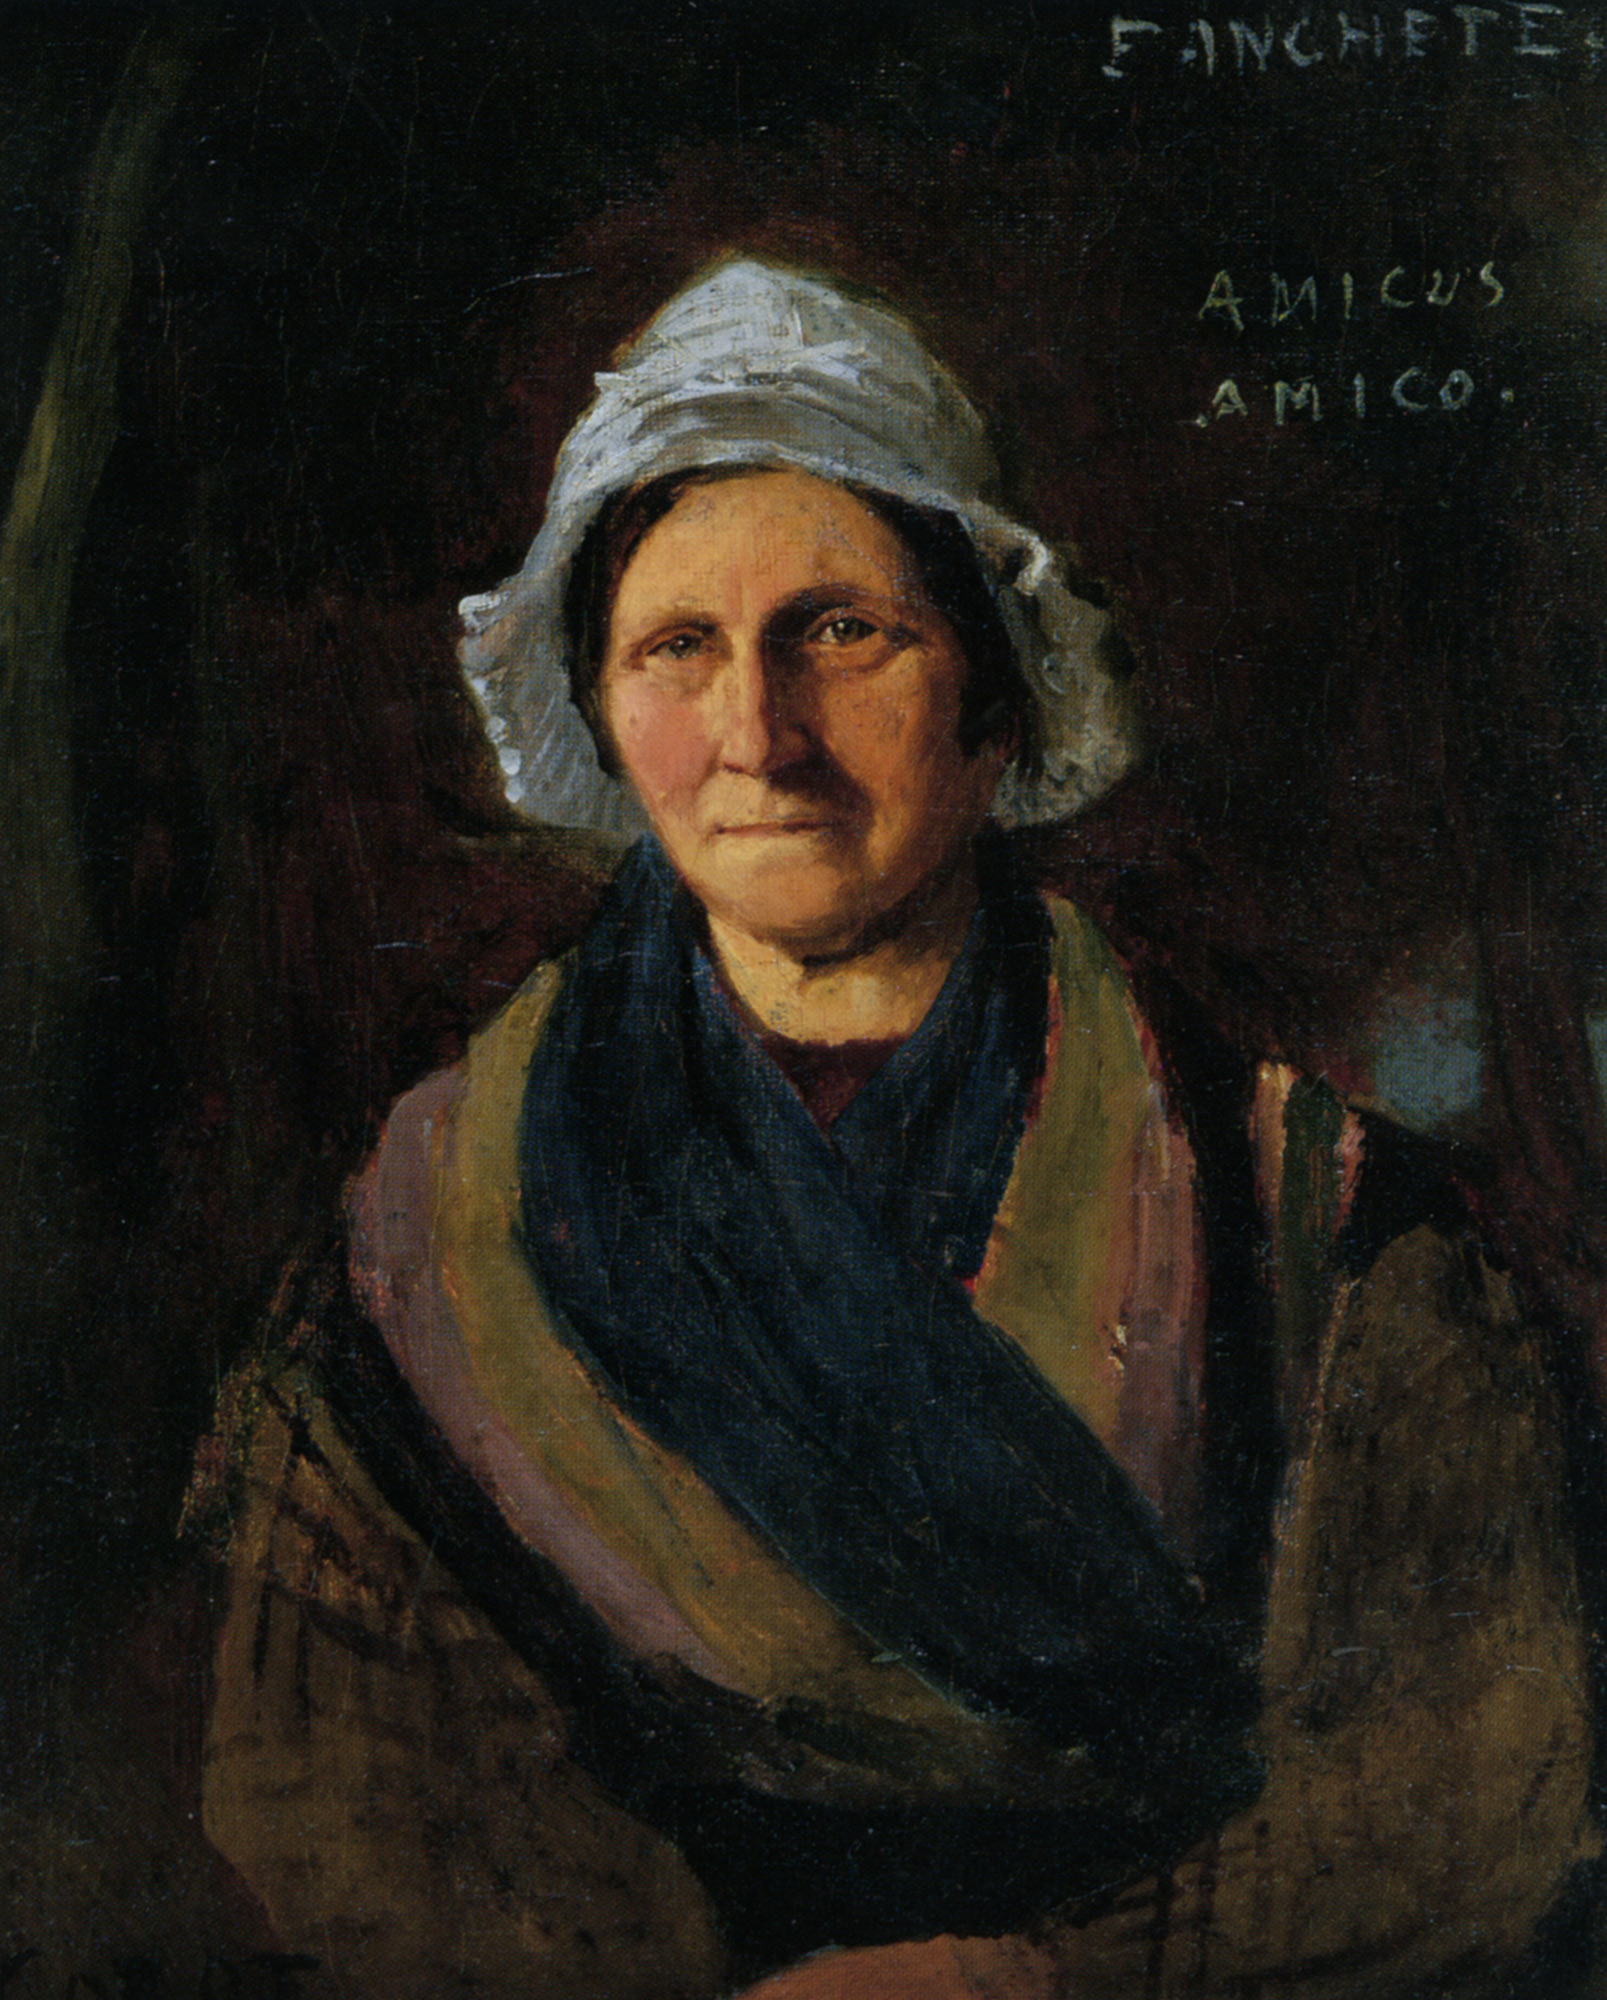What emotions do you think the artist intended to portray through the woman's expression and posture? The artist seems to capture a profound sense of resilience and subdued strength in the woman's expression. Her slightly furrowed brows and firm mouth convey a stoic endurance, possibly reflecting the challenges of her daily life or her character. The posture is upright yet relaxed, indicating a natural grace and a sense of calm despite any hardships. 